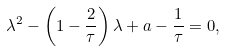Convert formula to latex. <formula><loc_0><loc_0><loc_500><loc_500>\lambda ^ { 2 } - \left ( 1 - \frac { 2 } { \tau } \right ) \lambda + a - \frac { 1 } { \tau } = 0 ,</formula> 